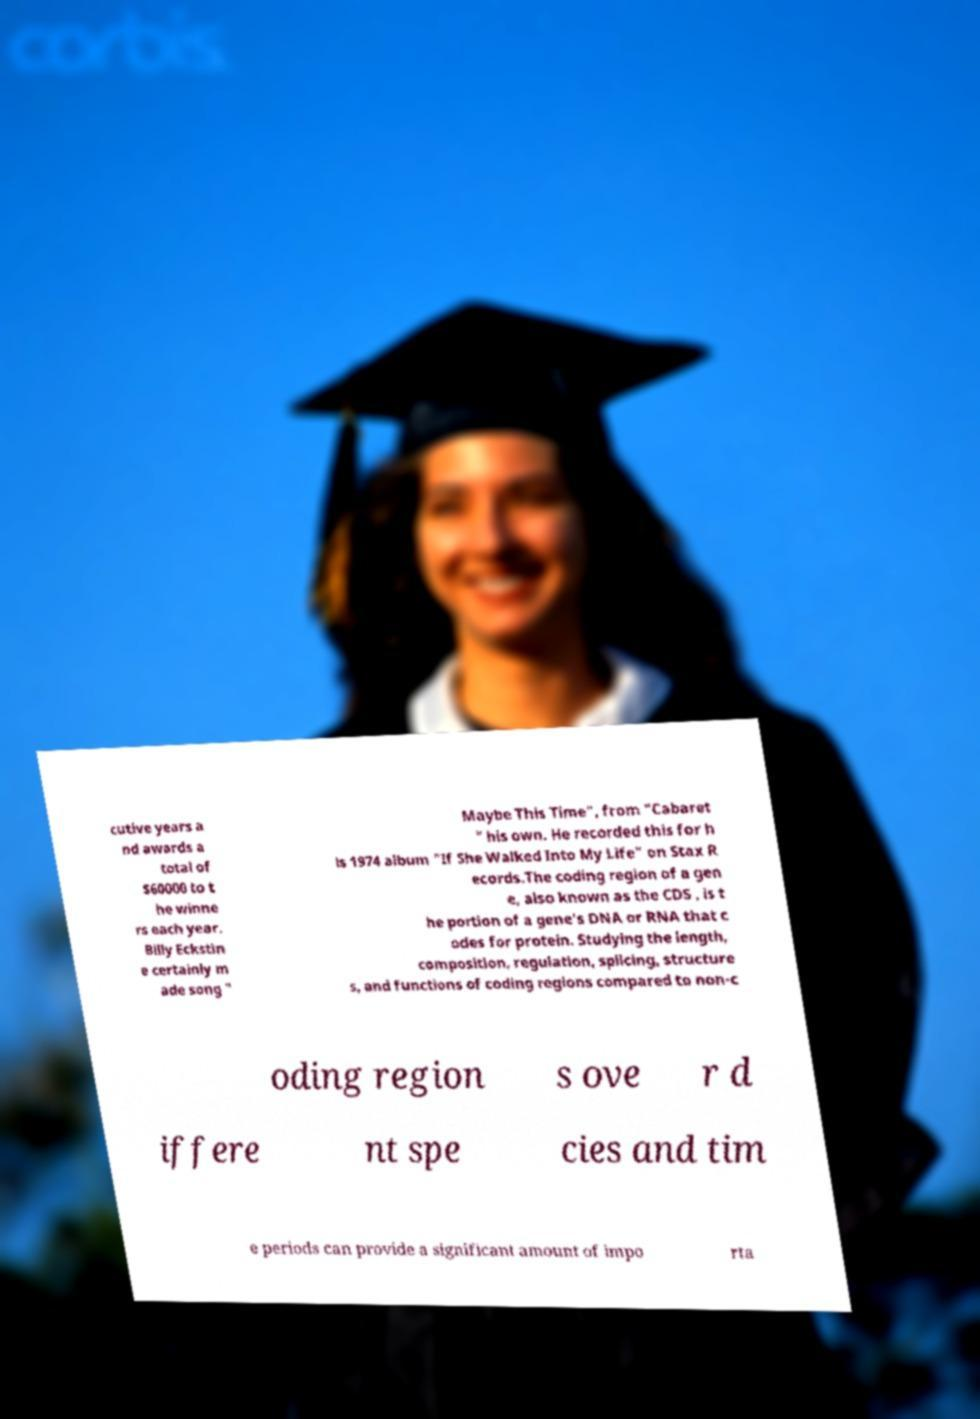Can you read and provide the text displayed in the image?This photo seems to have some interesting text. Can you extract and type it out for me? cutive years a nd awards a total of $60000 to t he winne rs each year. Billy Eckstin e certainly m ade song " Maybe This Time", from "Cabaret " his own. He recorded this for h is 1974 album "If She Walked Into My Life" on Stax R ecords.The coding region of a gen e, also known as the CDS , is t he portion of a gene's DNA or RNA that c odes for protein. Studying the length, composition, regulation, splicing, structure s, and functions of coding regions compared to non-c oding region s ove r d iffere nt spe cies and tim e periods can provide a significant amount of impo rta 